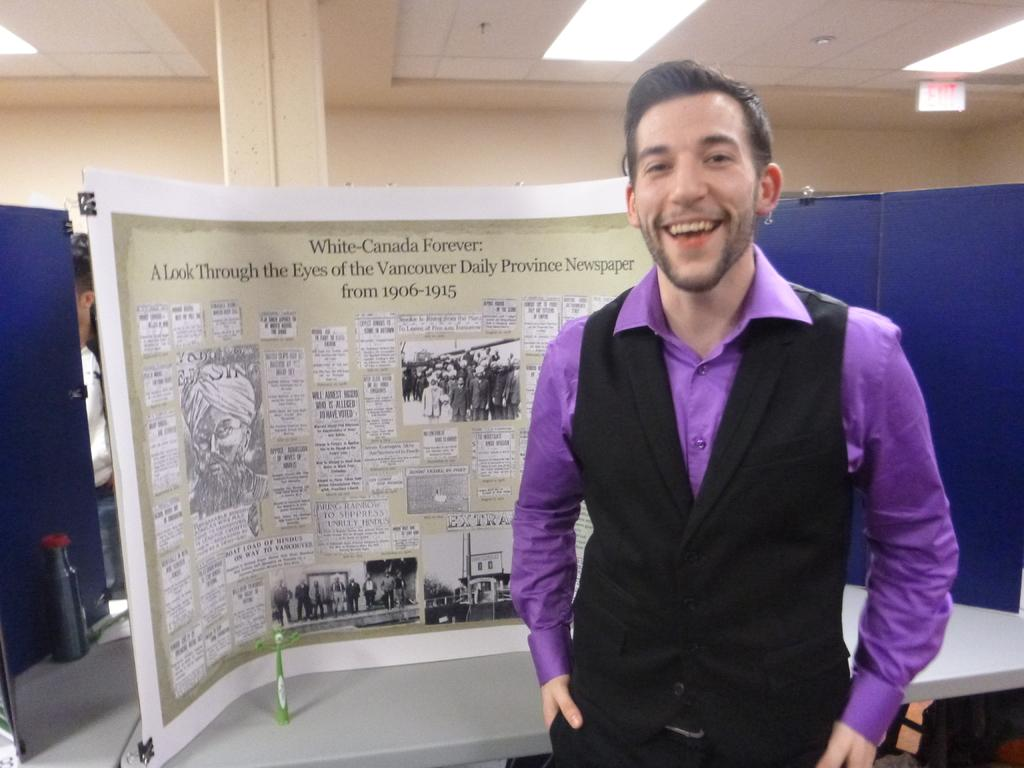Who is present in the image? There is a man in the image. What is the man doing in the image? The man is standing in the image. What can be seen on the walls in the image? There are notice boards in the image. What architectural feature is present in the image? There is a pillar in the image. What is visible on the ceiling in the image? There are lights on the ceiling in the image. What type of food is being served in the image? There is no food present in the image. What is the level of pollution in the image? The level of pollution cannot be determined from the image, as there is no indication of pollution present. 